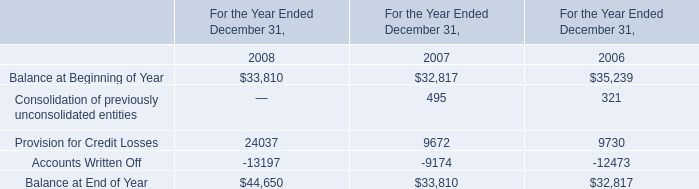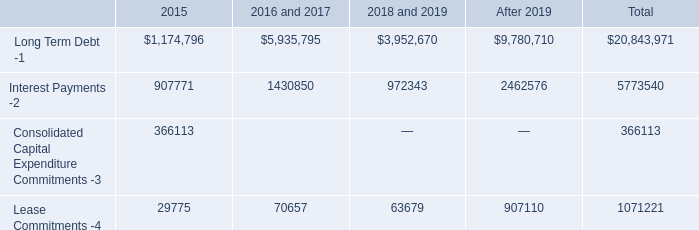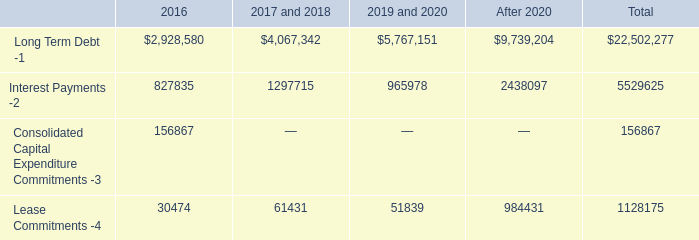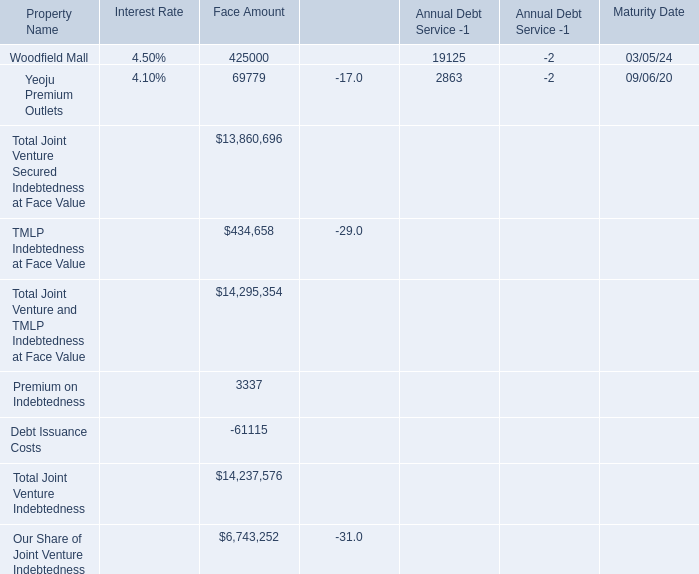How much is the 50 % of the Face Amount for TMLP Indebtedness at Face Value higher than the Face Amount for Premium on Indebtedness? 
Computations: ((0.5 * 434658) - 3337)
Answer: 213992.0. 